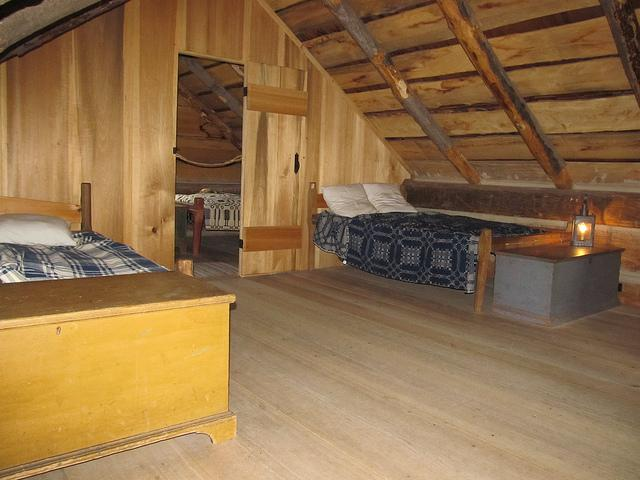What color of light is emanated by the lantern on the top of the footlocker? yellow 